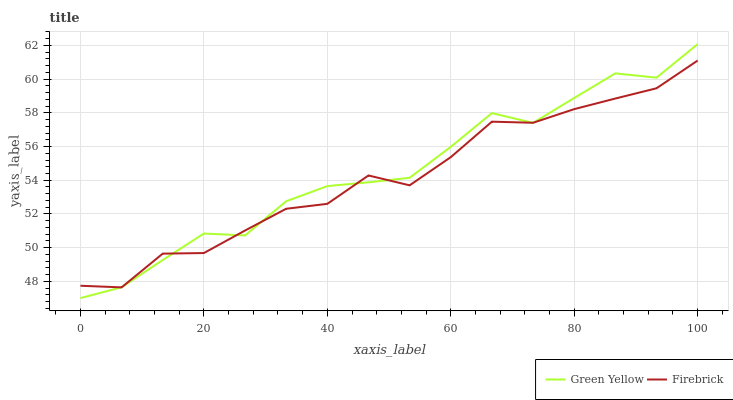Does Green Yellow have the minimum area under the curve?
Answer yes or no. No. Is Green Yellow the roughest?
Answer yes or no. No. 